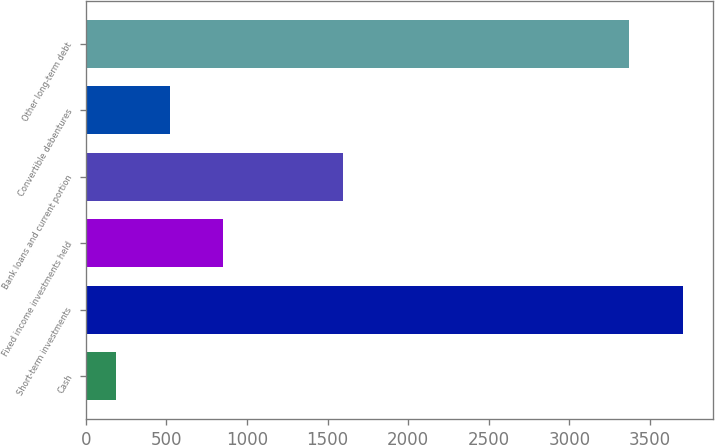Convert chart to OTSL. <chart><loc_0><loc_0><loc_500><loc_500><bar_chart><fcel>Cash<fcel>Short-term investments<fcel>Fixed income investments held<fcel>Bank loans and current portion<fcel>Convertible debentures<fcel>Other long-term debt<nl><fcel>189<fcel>3703.4<fcel>851.8<fcel>1598<fcel>520.4<fcel>3372<nl></chart> 